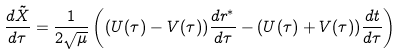<formula> <loc_0><loc_0><loc_500><loc_500>\frac { d \tilde { X } } { d \tau } = \frac { 1 } { 2 \sqrt { \mu } } \left ( ( U ( \tau ) - V ( \tau ) ) \frac { d r ^ { * } } { d \tau } - ( U ( \tau ) + V ( \tau ) ) \frac { d t } { d \tau } \right )</formula> 